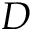Convert formula to latex. <formula><loc_0><loc_0><loc_500><loc_500>D</formula> 